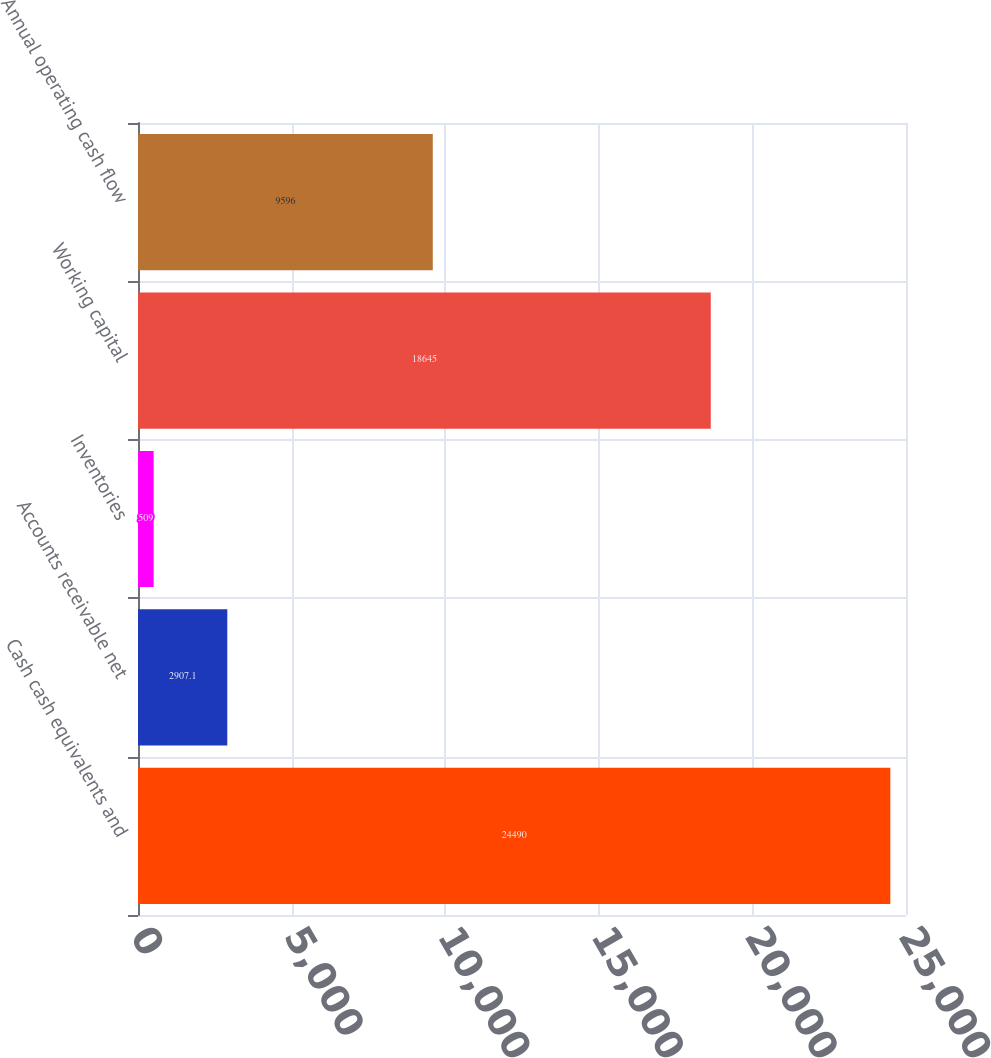Convert chart to OTSL. <chart><loc_0><loc_0><loc_500><loc_500><bar_chart><fcel>Cash cash equivalents and<fcel>Accounts receivable net<fcel>Inventories<fcel>Working capital<fcel>Annual operating cash flow<nl><fcel>24490<fcel>2907.1<fcel>509<fcel>18645<fcel>9596<nl></chart> 